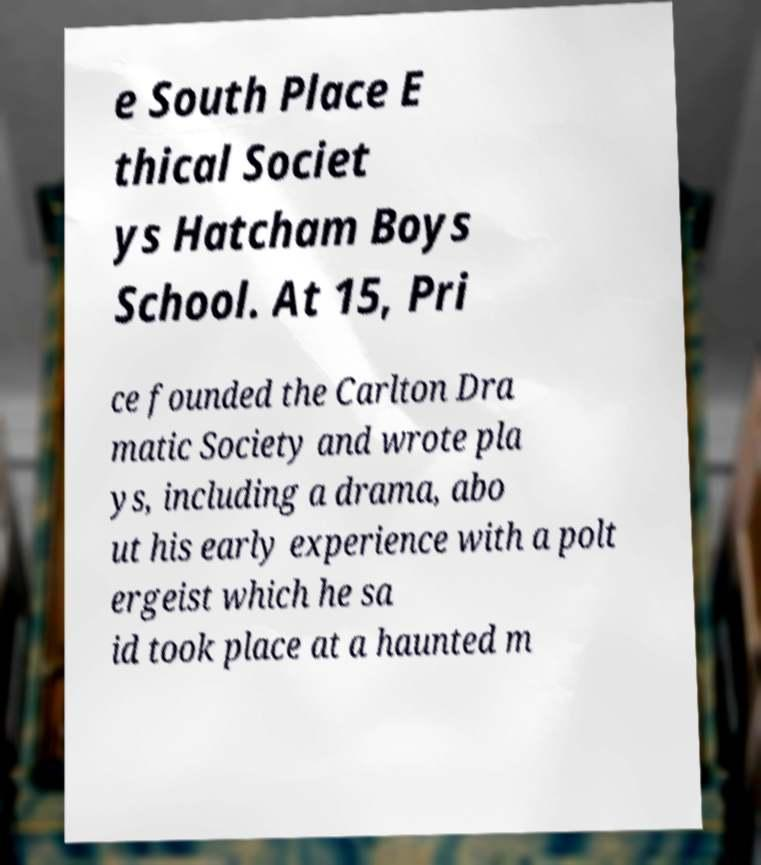Could you assist in decoding the text presented in this image and type it out clearly? e South Place E thical Societ ys Hatcham Boys School. At 15, Pri ce founded the Carlton Dra matic Society and wrote pla ys, including a drama, abo ut his early experience with a polt ergeist which he sa id took place at a haunted m 